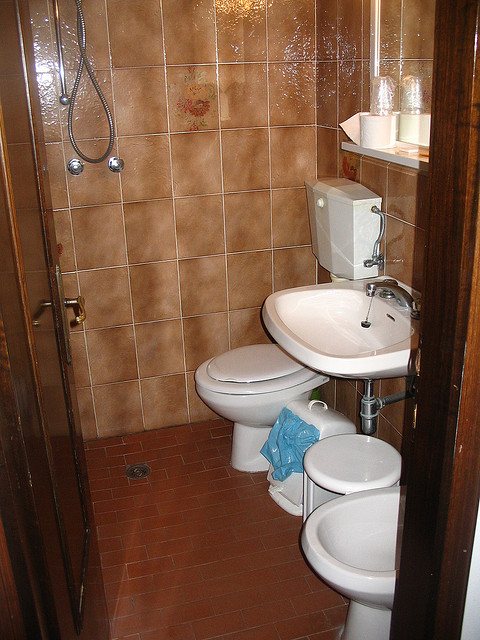How many toilets are in the picture? 2 